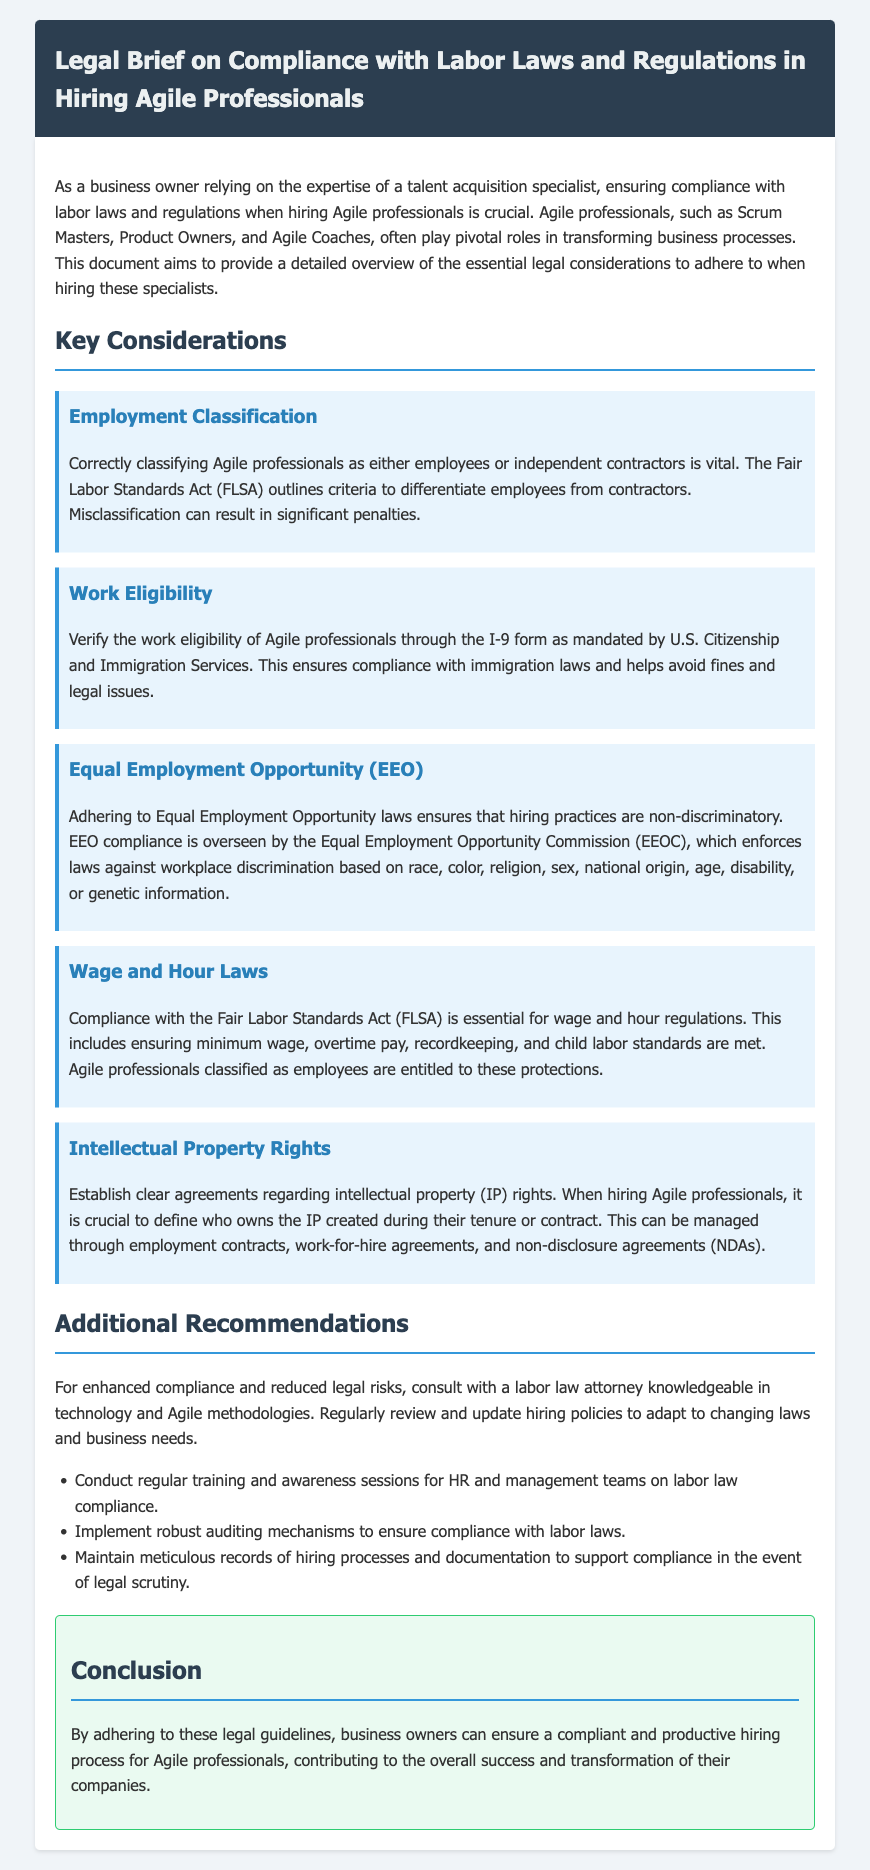What is the primary focus of this legal brief? The primary focus is on compliance with labor laws and regulations when hiring Agile professionals.
Answer: compliance with labor laws and regulations when hiring Agile professionals What does FLSA stand for? FLSA is mentioned in relation to employment classification and wage laws.
Answer: Fair Labor Standards Act What must you verify to ensure work eligibility? The document emphasizes the necessity of verifying work eligibility through a specific form.
Answer: I-9 form Which agency oversees Equal Employment Opportunity compliance? The document specifies the agency responsible for enforcing EEO laws.
Answer: Equal Employment Opportunity Commission (EEOC) What type of agreements should be established regarding intellectual property? The document suggests a type of agreement related to intellectual property ownership.
Answer: employment contracts How many key considerations are listed in the document? The document outlines a specific number of key considerations related to hiring.
Answer: five What should business owners regularly review to ensure compliance? The document mentions a particular action to maintain compliance in hiring practices.
Answer: hiring policies Which group is recommended for consultation to ensure compliance? The document suggests a type of professional for legal guidance.
Answer: labor law attorney What are the two primary types of workers mentioned in employment classification? The document discusses classifications that are crucial for legal compliance.
Answer: employees or independent contractors 